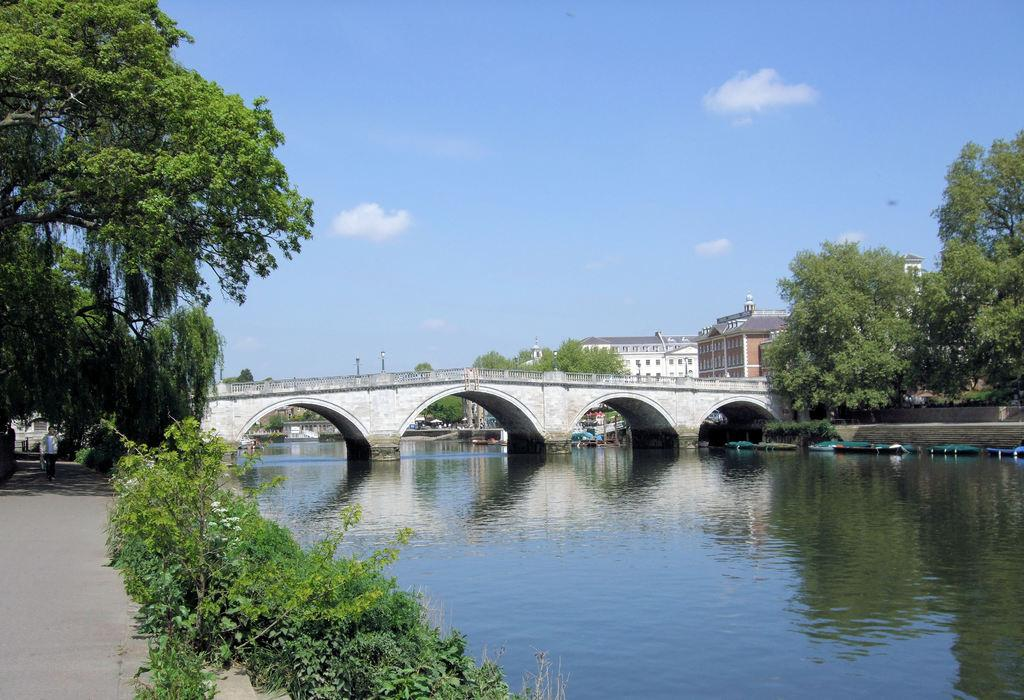What type of water feature is present in the image? There is a canal in the image. What structure can be seen crossing over the canal? There is a bridge in the image. What type of vegetation is present in the image? There are trees and plants in the image. What type of man-made structures can be seen in the image? There are buildings in the image. Can you read the letter that is hanging from the tree in the image? There is no letter hanging from a tree in the image; it only features a canal, a bridge, trees, plants, and buildings. What type of lamp is illuminating the bridge in the image? There is no lamp present in the image; it only features a canal, a bridge, trees, plants, and buildings. 